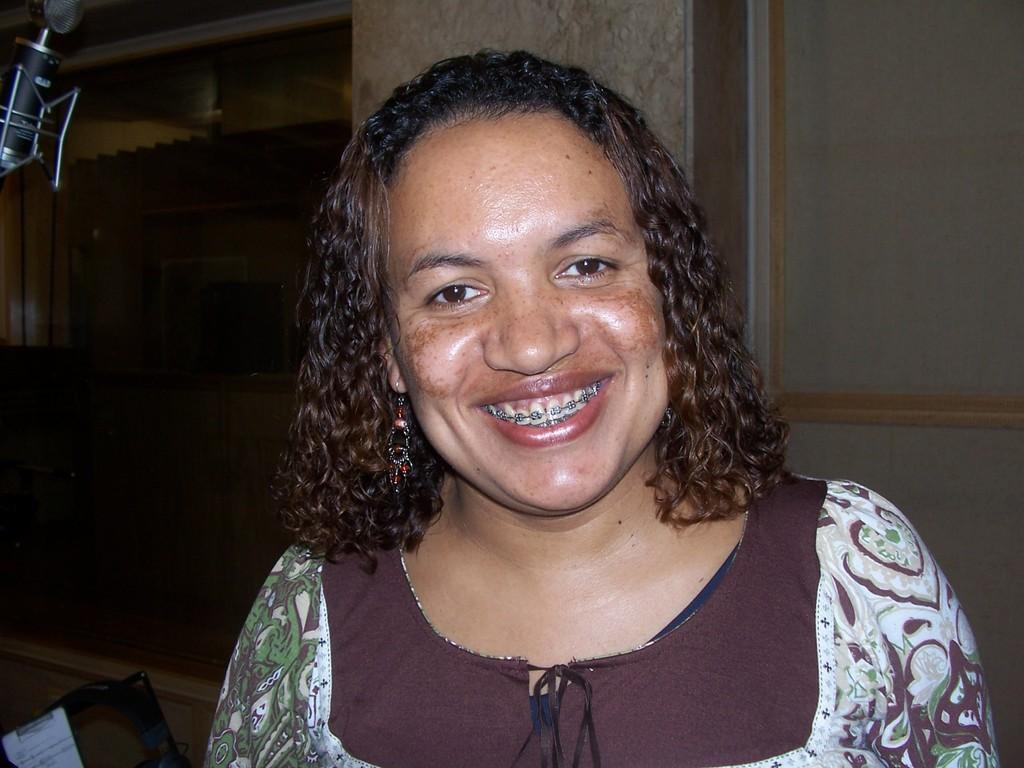Who is present in the image? There is a lady in the image. What can be seen on the left side of the image? There is an object at the left side of the image. What is located at the bottom of the image? There is an object at the bottom of the image. What type of goat is demanding attention in the image? There is no goat present in the image, and therefore no such interaction can be observed. 